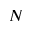Convert formula to latex. <formula><loc_0><loc_0><loc_500><loc_500>N</formula> 